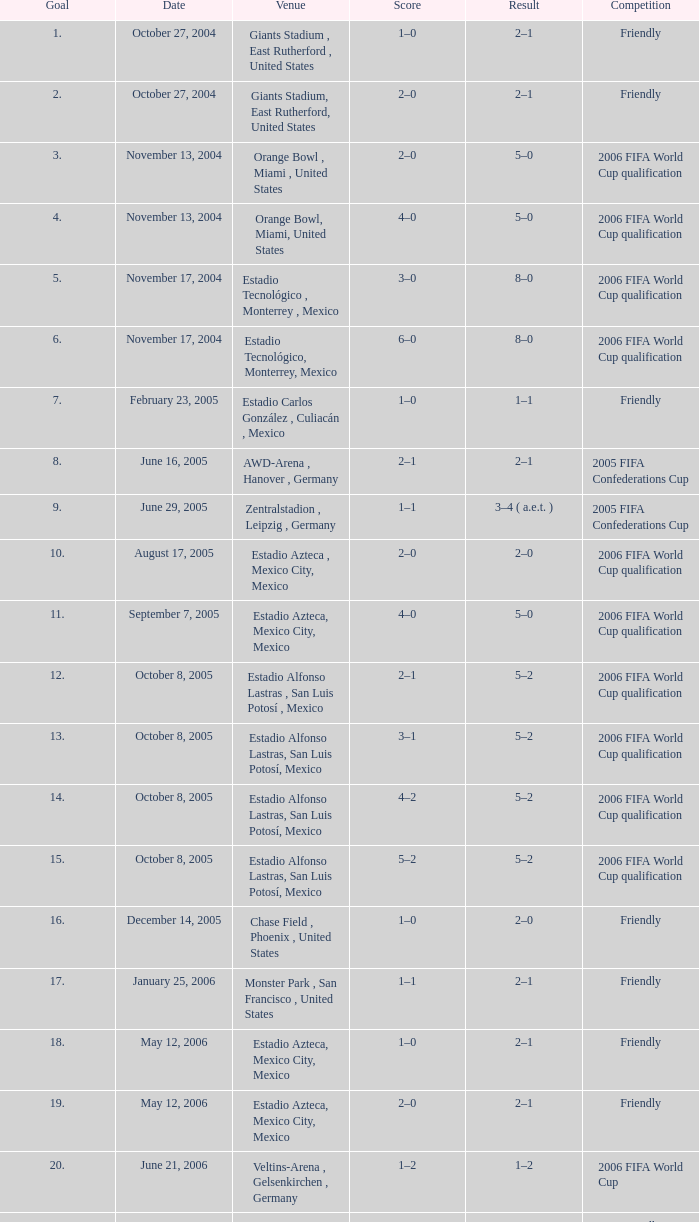In a friendly competition with a 2-1 result, which score has a goal count less than 17? 1–0, 2–0. Write the full table. {'header': ['Goal', 'Date', 'Venue', 'Score', 'Result', 'Competition'], 'rows': [['1.', 'October 27, 2004', 'Giants Stadium , East Rutherford , United States', '1–0', '2–1', 'Friendly'], ['2.', 'October 27, 2004', 'Giants Stadium, East Rutherford, United States', '2–0', '2–1', 'Friendly'], ['3.', 'November 13, 2004', 'Orange Bowl , Miami , United States', '2–0', '5–0', '2006 FIFA World Cup qualification'], ['4.', 'November 13, 2004', 'Orange Bowl, Miami, United States', '4–0', '5–0', '2006 FIFA World Cup qualification'], ['5.', 'November 17, 2004', 'Estadio Tecnológico , Monterrey , Mexico', '3–0', '8–0', '2006 FIFA World Cup qualification'], ['6.', 'November 17, 2004', 'Estadio Tecnológico, Monterrey, Mexico', '6–0', '8–0', '2006 FIFA World Cup qualification'], ['7.', 'February 23, 2005', 'Estadio Carlos González , Culiacán , Mexico', '1–0', '1–1', 'Friendly'], ['8.', 'June 16, 2005', 'AWD-Arena , Hanover , Germany', '2–1', '2–1', '2005 FIFA Confederations Cup'], ['9.', 'June 29, 2005', 'Zentralstadion , Leipzig , Germany', '1–1', '3–4 ( a.e.t. )', '2005 FIFA Confederations Cup'], ['10.', 'August 17, 2005', 'Estadio Azteca , Mexico City, Mexico', '2–0', '2–0', '2006 FIFA World Cup qualification'], ['11.', 'September 7, 2005', 'Estadio Azteca, Mexico City, Mexico', '4–0', '5–0', '2006 FIFA World Cup qualification'], ['12.', 'October 8, 2005', 'Estadio Alfonso Lastras , San Luis Potosí , Mexico', '2–1', '5–2', '2006 FIFA World Cup qualification'], ['13.', 'October 8, 2005', 'Estadio Alfonso Lastras, San Luis Potosí, Mexico', '3–1', '5–2', '2006 FIFA World Cup qualification'], ['14.', 'October 8, 2005', 'Estadio Alfonso Lastras, San Luis Potosí, Mexico', '4–2', '5–2', '2006 FIFA World Cup qualification'], ['15.', 'October 8, 2005', 'Estadio Alfonso Lastras, San Luis Potosí, Mexico', '5–2', '5–2', '2006 FIFA World Cup qualification'], ['16.', 'December 14, 2005', 'Chase Field , Phoenix , United States', '1–0', '2–0', 'Friendly'], ['17.', 'January 25, 2006', 'Monster Park , San Francisco , United States', '1–1', '2–1', 'Friendly'], ['18.', 'May 12, 2006', 'Estadio Azteca, Mexico City, Mexico', '1–0', '2–1', 'Friendly'], ['19.', 'May 12, 2006', 'Estadio Azteca, Mexico City, Mexico', '2–0', '2–1', 'Friendly'], ['20.', 'June 21, 2006', 'Veltins-Arena , Gelsenkirchen , Germany', '1–2', '1–2', '2006 FIFA World Cup'], ['21.', 'June 2, 2007', 'Estadio Alfonso Lastras, San Luis Potosí, Mexico', '3–0', '4–0', 'Friendly']]} 